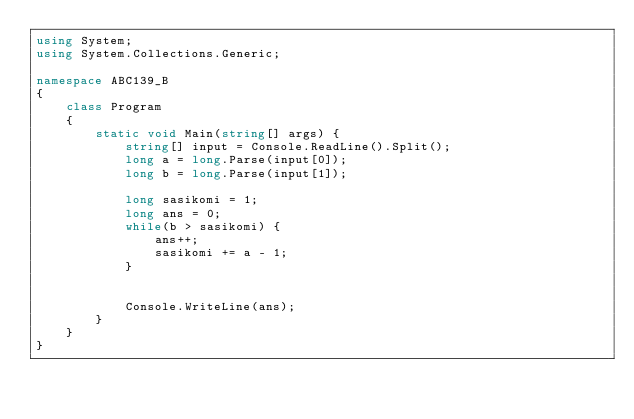<code> <loc_0><loc_0><loc_500><loc_500><_C#_>using System;
using System.Collections.Generic;

namespace ABC139_B
{
    class Program
    {
        static void Main(string[] args) {
            string[] input = Console.ReadLine().Split();
            long a = long.Parse(input[0]);
            long b = long.Parse(input[1]);

            long sasikomi = 1;
            long ans = 0;
            while(b > sasikomi) {
                ans++;
                sasikomi += a - 1;
            }

            
            Console.WriteLine(ans);
        }
    }
}</code> 